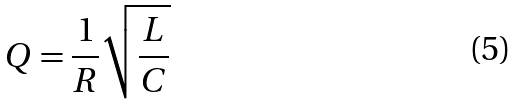<formula> <loc_0><loc_0><loc_500><loc_500>Q = \frac { 1 } { R } \sqrt { \frac { L } { C } }</formula> 